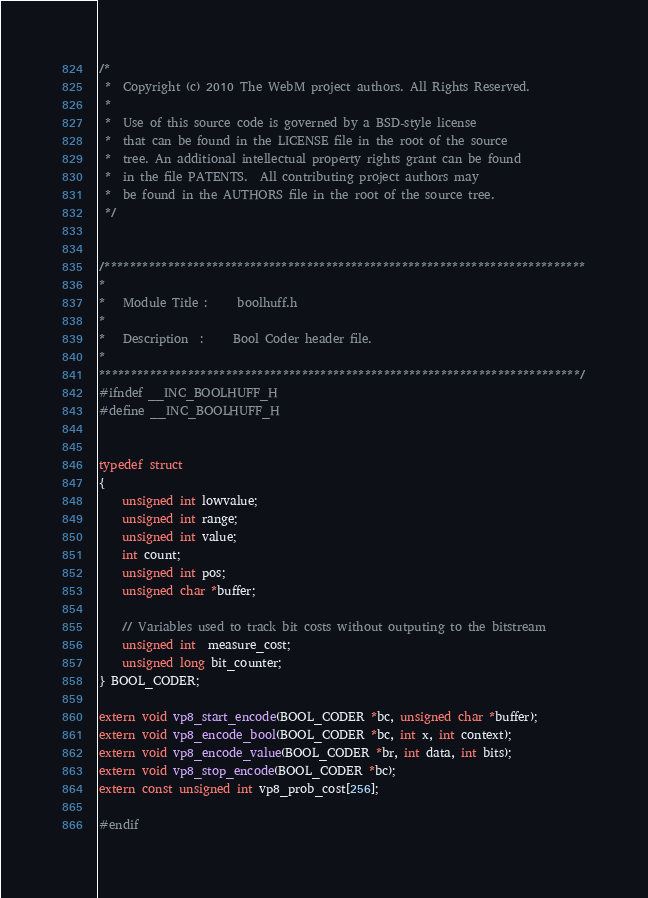Convert code to text. <code><loc_0><loc_0><loc_500><loc_500><_C_>/*
 *  Copyright (c) 2010 The WebM project authors. All Rights Reserved.
 *
 *  Use of this source code is governed by a BSD-style license
 *  that can be found in the LICENSE file in the root of the source
 *  tree. An additional intellectual property rights grant can be found
 *  in the file PATENTS.  All contributing project authors may
 *  be found in the AUTHORS file in the root of the source tree.
 */


/****************************************************************************
*
*   Module Title :     boolhuff.h
*
*   Description  :     Bool Coder header file.
*
****************************************************************************/
#ifndef __INC_BOOLHUFF_H
#define __INC_BOOLHUFF_H


typedef struct
{
    unsigned int lowvalue;
    unsigned int range;
    unsigned int value;
    int count;
    unsigned int pos;
    unsigned char *buffer;

    // Variables used to track bit costs without outputing to the bitstream
    unsigned int  measure_cost;
    unsigned long bit_counter;
} BOOL_CODER;

extern void vp8_start_encode(BOOL_CODER *bc, unsigned char *buffer);
extern void vp8_encode_bool(BOOL_CODER *bc, int x, int context);
extern void vp8_encode_value(BOOL_CODER *br, int data, int bits);
extern void vp8_stop_encode(BOOL_CODER *bc);
extern const unsigned int vp8_prob_cost[256];

#endif
</code> 